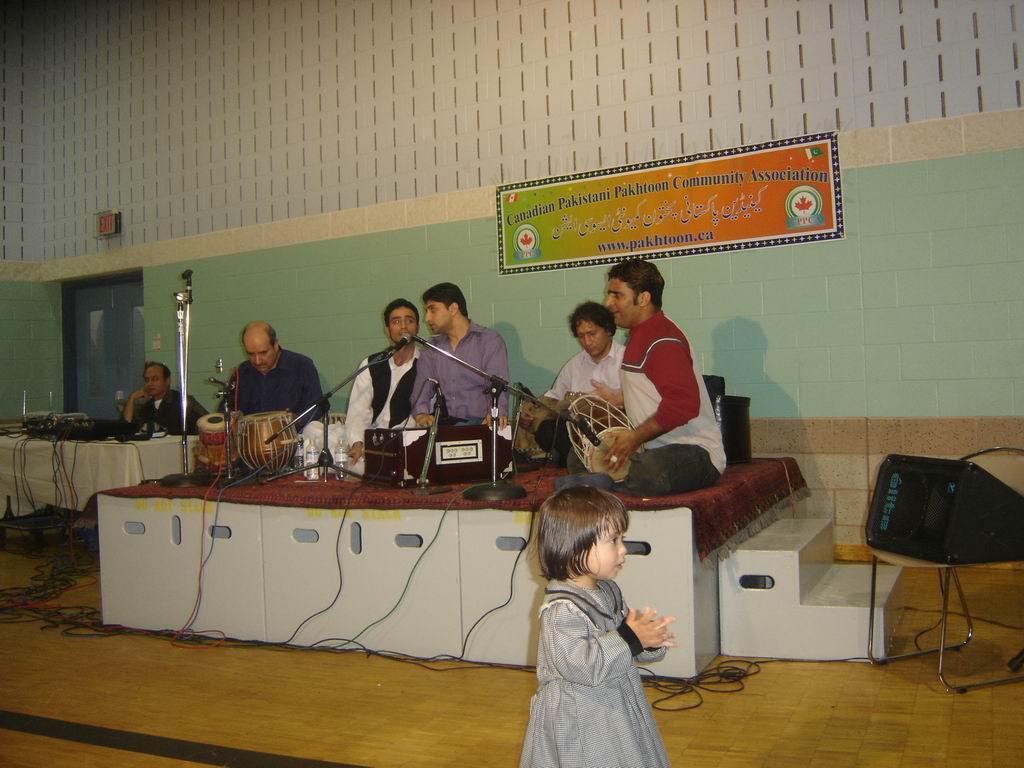Please provide a concise description of this image. This picture is taken inside the room. In this image, in the middle, we can see a girl standing on the floor. In the middle of the image, we can see a stage, on the stage, we can see a group of people sitting and playing the musical instrument in front of a microphone. On the right side, we can see a chair, on the chair, we can see a black color object. On the left side, we can also a man sitting in front of the table, on the table, we can see a white color cloth and some electronic instrument, electrical wires. In the background, we can see a board, on the board, we can see some text and pictures. On the left side, we can also see a door which is closed. In the background, we can see a wall, at the bottom, we can see some electrical wires on the floor. 